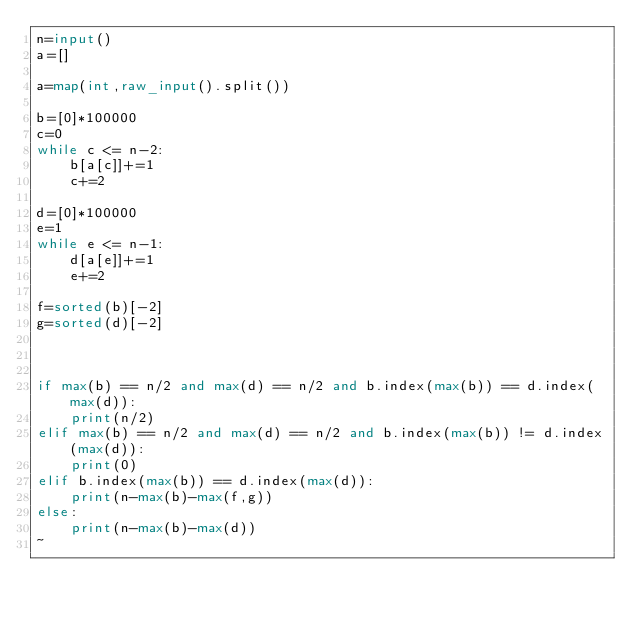<code> <loc_0><loc_0><loc_500><loc_500><_Python_>n=input()
a=[]

a=map(int,raw_input().split())

b=[0]*100000
c=0
while c <= n-2:
    b[a[c]]+=1
    c+=2

d=[0]*100000
e=1
while e <= n-1:
    d[a[e]]+=1
    e+=2

f=sorted(b)[-2]
g=sorted(d)[-2]



if max(b) == n/2 and max(d) == n/2 and b.index(max(b)) == d.index(max(d)):
    print(n/2)
elif max(b) == n/2 and max(d) == n/2 and b.index(max(b)) != d.index(max(d)):
    print(0)
elif b.index(max(b)) == d.index(max(d)):
    print(n-max(b)-max(f,g))
else:
    print(n-max(b)-max(d))
~                              </code> 